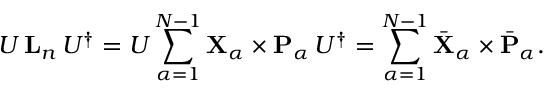Convert formula to latex. <formula><loc_0><loc_0><loc_500><loc_500>U \, { L } _ { n } \, U ^ { \dagger } = U \sum _ { \alpha = 1 } ^ { N - 1 } { X } _ { \alpha } \times { P } _ { \alpha } \, U ^ { \dagger } = \sum _ { \alpha = 1 } ^ { N - 1 } \bar { X } _ { \alpha } \times \bar { P } _ { \alpha } .</formula> 